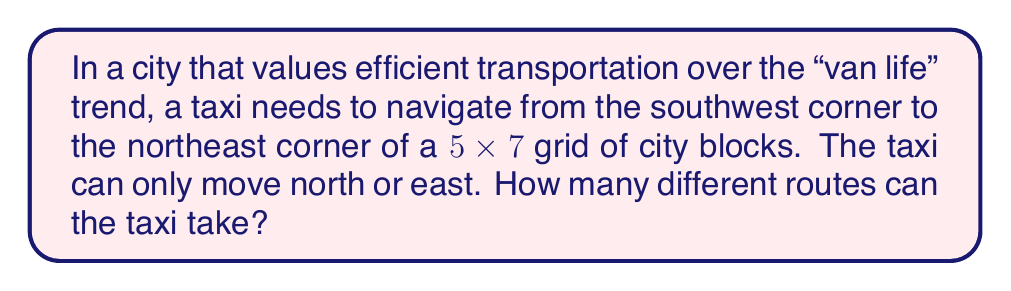Can you answer this question? Let's approach this step-by-step:

1) First, we need to understand what the question is asking. The taxi needs to go from one corner to the opposite corner of a grid that is 5 blocks wide and 7 blocks tall.

2) To reach the destination, the taxi must go:
   - 5 blocks east (E)
   - 7 blocks north (N)

3) The total number of moves is always 12 (5 + 7), regardless of the route taken.

4) This problem is equivalent to asking: "In how many ways can we arrange 5 E's and 7 N's in a sequence?"

5) This is a combination problem. We need to choose positions for either the E's or the N's (choosing one automatically determines the other).

6) We can solve this using the combination formula:

   $$\binom{12}{5} = \binom{12}{7}$$

7) This can be calculated as:

   $$\binom{12}{5} = \frac{12!}{5!(12-5)!} = \frac{12!}{5!7!}$$

8) Expanding this:

   $$\frac{12 \times 11 \times 10 \times 9 \times 8}{5 \times 4 \times 3 \times 2 \times 1} = 792$$

Therefore, there are 792 different routes the taxi can take.
Answer: 792 